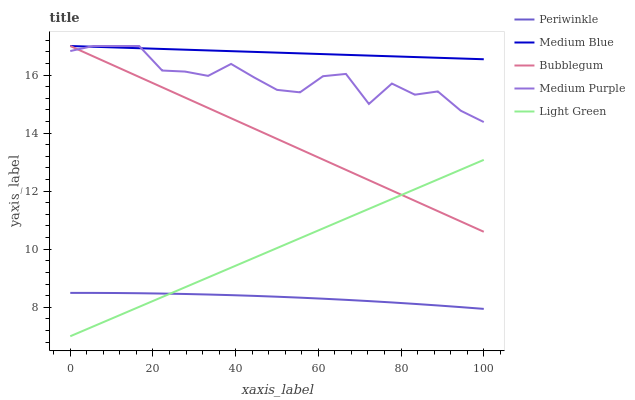Does Periwinkle have the minimum area under the curve?
Answer yes or no. Yes. Does Medium Blue have the maximum area under the curve?
Answer yes or no. Yes. Does Medium Blue have the minimum area under the curve?
Answer yes or no. No. Does Periwinkle have the maximum area under the curve?
Answer yes or no. No. Is Bubblegum the smoothest?
Answer yes or no. Yes. Is Medium Purple the roughest?
Answer yes or no. Yes. Is Medium Blue the smoothest?
Answer yes or no. No. Is Medium Blue the roughest?
Answer yes or no. No. Does Light Green have the lowest value?
Answer yes or no. Yes. Does Periwinkle have the lowest value?
Answer yes or no. No. Does Bubblegum have the highest value?
Answer yes or no. Yes. Does Periwinkle have the highest value?
Answer yes or no. No. Is Periwinkle less than Medium Blue?
Answer yes or no. Yes. Is Medium Blue greater than Periwinkle?
Answer yes or no. Yes. Does Medium Blue intersect Medium Purple?
Answer yes or no. Yes. Is Medium Blue less than Medium Purple?
Answer yes or no. No. Is Medium Blue greater than Medium Purple?
Answer yes or no. No. Does Periwinkle intersect Medium Blue?
Answer yes or no. No. 